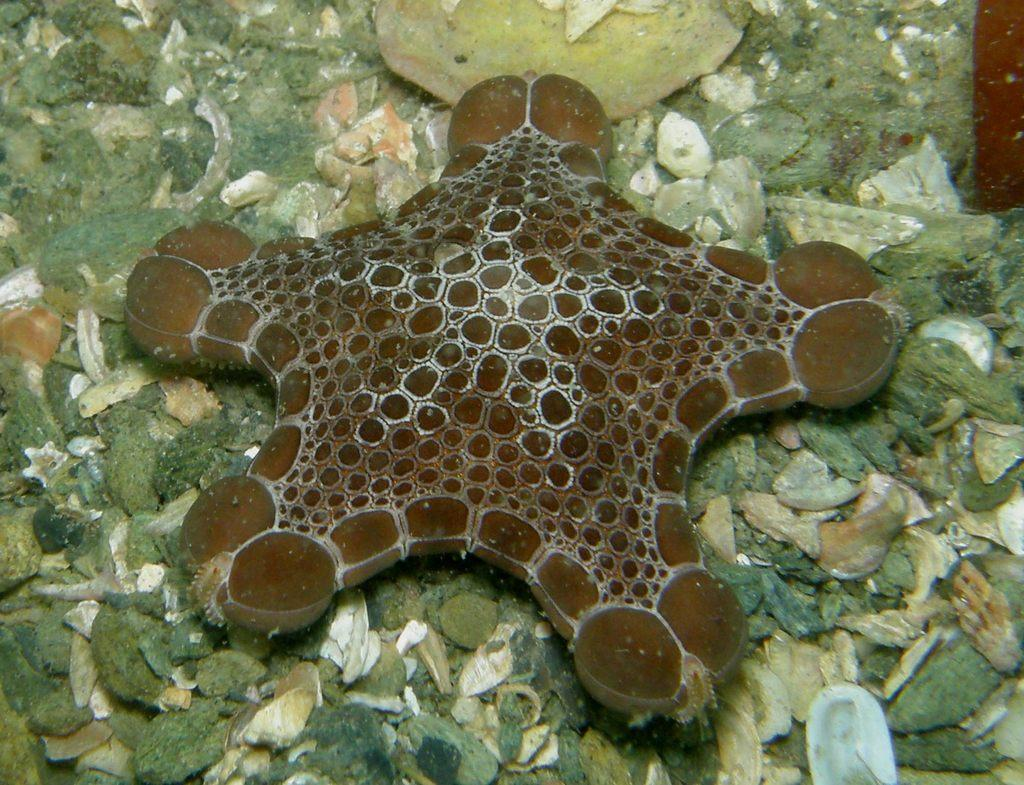What type of animal is in the image? There is an aquatic animal in the image. What color is the aquatic animal? The aquatic animal is brown in color. What can be seen in the background of the image? There are rocks in the background of the image. What colors are the rocks? The rocks are in white, brown, and ash colors. What statement does the twig make in the image? There is no twig present in the image, so it cannot make any statements. 